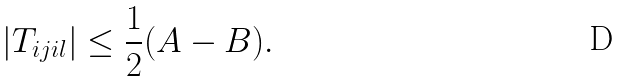<formula> <loc_0><loc_0><loc_500><loc_500>| T _ { i j i l } | \leq \frac { 1 } { 2 } ( A - B ) .</formula> 